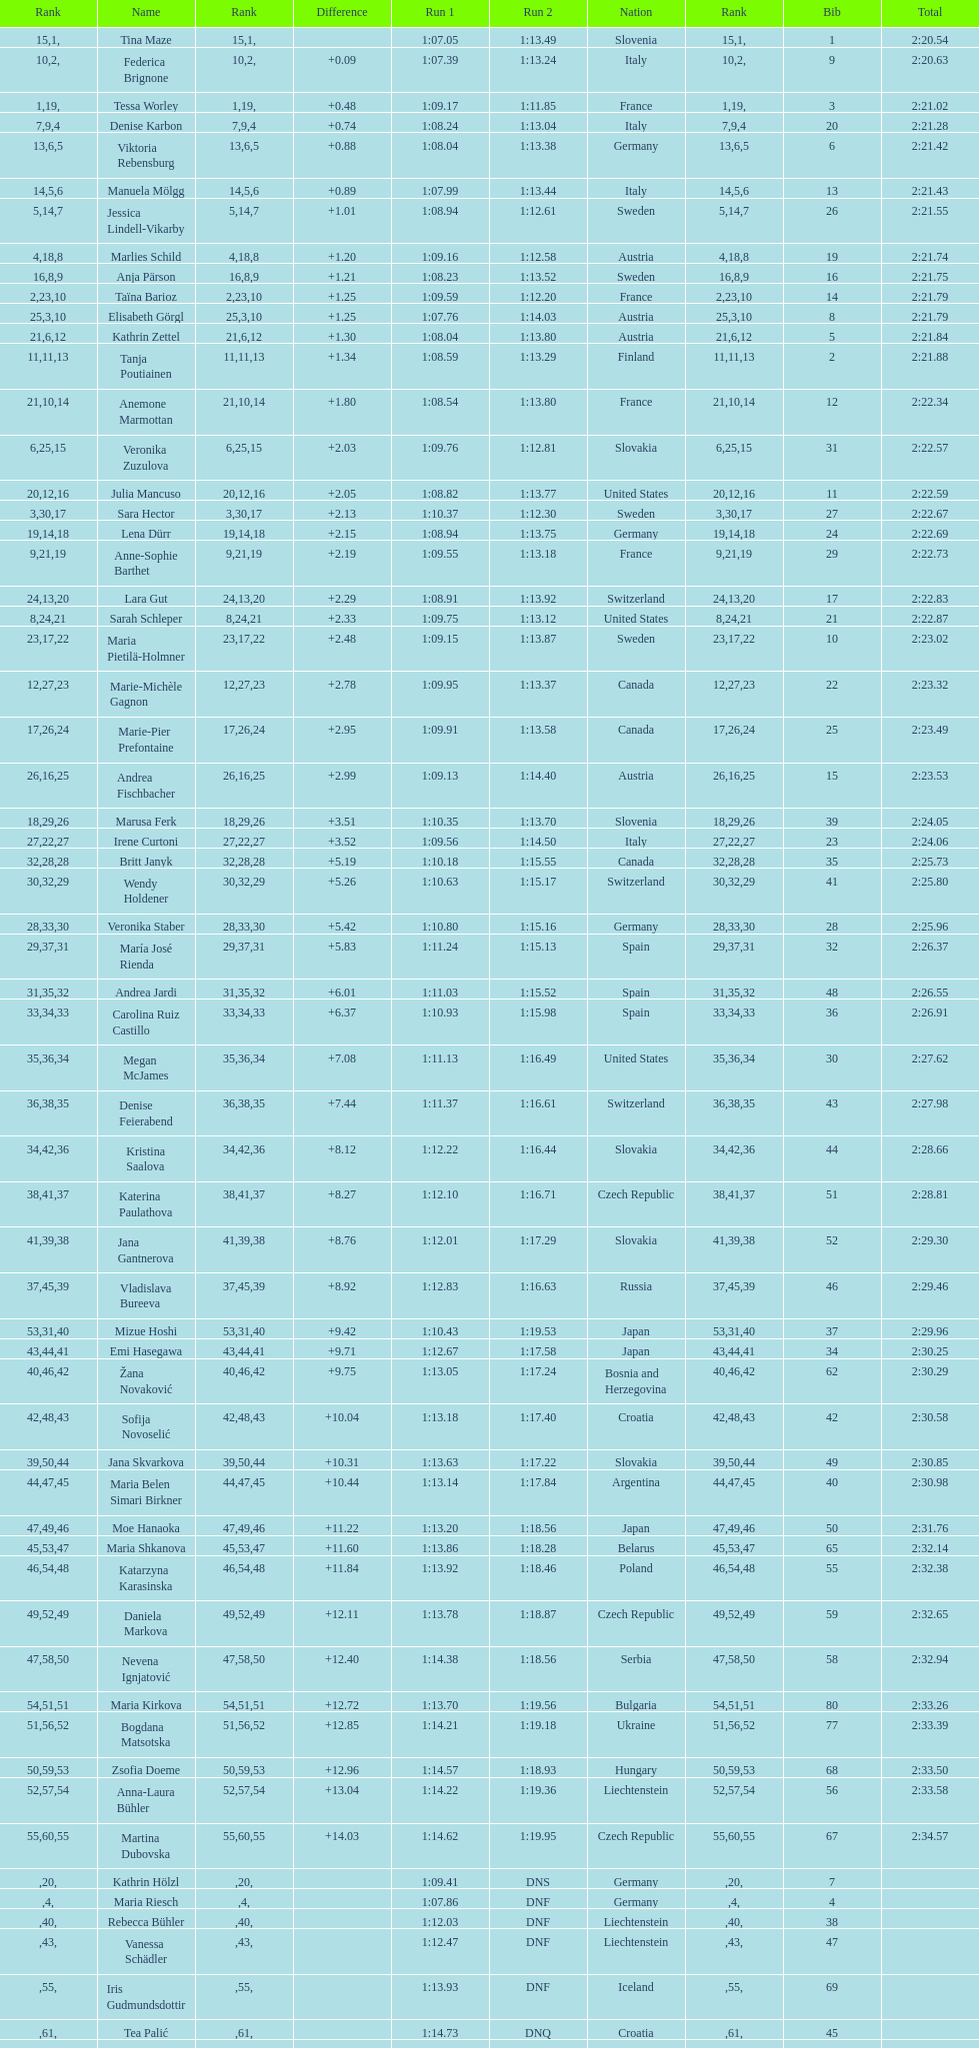Who ranked next after federica brignone? Tessa Worley. 